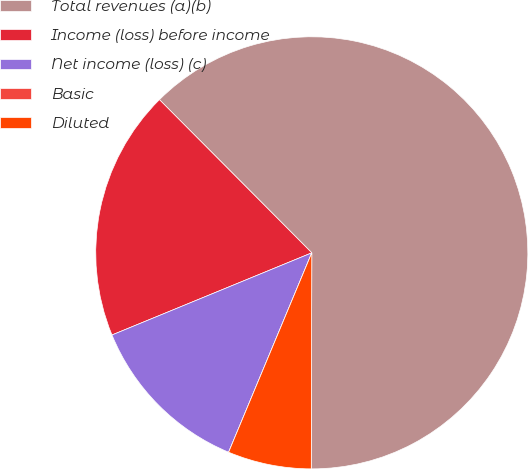<chart> <loc_0><loc_0><loc_500><loc_500><pie_chart><fcel>Total revenues (a)(b)<fcel>Income (loss) before income<fcel>Net income (loss) (c)<fcel>Basic<fcel>Diluted<nl><fcel>62.49%<fcel>18.75%<fcel>12.5%<fcel>0.0%<fcel>6.25%<nl></chart> 